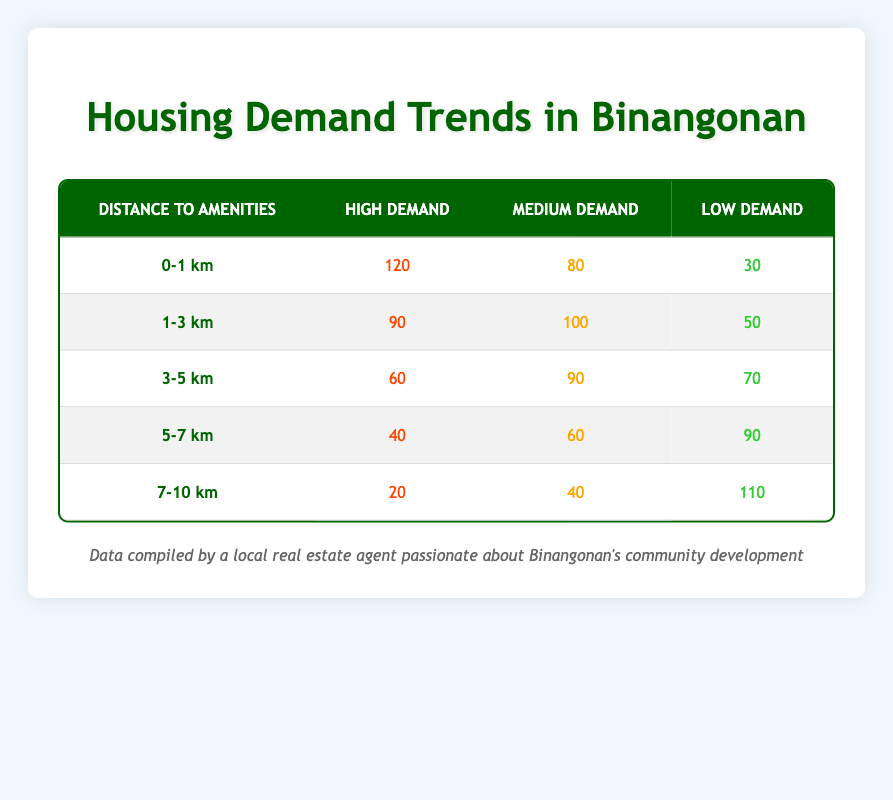What is the housing demand categorized as "High" for properties that are 0-1 km away from amenities? The table shows that for properties located in the 0-1 km distance category, the "High Demand" value is 120.
Answer: 120 What is the total housing demand in the 1-3 km range? To find the total housing demand in the 1-3 km range, we add the values from the "High", "Medium", and "Low" demand categories: 90 (High) + 100 (Medium) + 50 (Low) = 240.
Answer: 240 Is there a greater demand for "Medium" housing in the 3-5 km range compared to the 5-7 km range? The "Medium" demand for the 3-5 km range is 90, while for the 5-7 km range it is 60. Therefore, 90 is greater than 60, so the statement is true.
Answer: Yes What is the average demand for "Low" housing across all distance categories? First, we identify the "Low" values: 30 (0-1 km), 50 (1-3 km), 70 (3-5 km), 90 (5-7 km), and 110 (7-10 km). The average is calculated by summing these values (30 + 50 + 70 + 90 + 110 = 350) and dividing by the number of categories (5): 350/5 = 70.
Answer: 70 For properties that are 7-10 km away from amenities, is the "Low" demand category the highest? The "Low" demand value in the 7-10 km category is 110, while the "Medium" is 40 and "High" is 20. Since 110 is the highest among these values, the statement is true.
Answer: Yes What is the difference in "High" housing demand between the 0-1 km range and the 3-5 km range? The "High" demand for 0-1 km is 120 and for 3-5 km is 60. The difference is calculated by subtracting 60 from 120: 120 - 60 = 60.
Answer: 60 What is the total number of "High" demand properties across all distance categories? To find the total "High" demand across all categories, we add the "High" values: 120 (0-1 km) + 90 (1-3 km) + 60 (3-5 km) + 40 (5-7 km) + 20 (7-10 km) = 420.
Answer: 420 What is the maximum demand for "Medium" housing in a single distance category? By examining the "Medium" values, we find 80 (0-1 km), 100 (1-3 km), 90 (3-5 km), 60 (5-7 km), and 40 (7-10 km). The maximum is identified as 100 from the 1-3 km range.
Answer: 100 